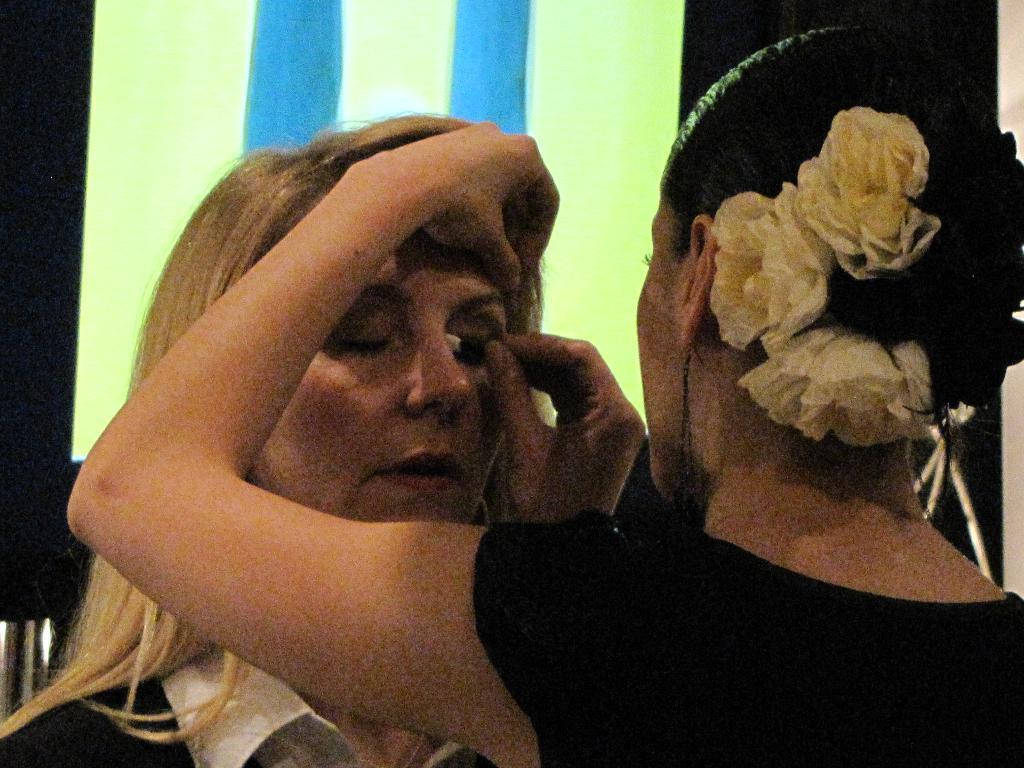What is happening in the image? In the image, there is a lady applying eye shadow to another lady. What can be seen in the background of the image? There is a board in the background of the image. What type of bird is sitting on the lady's shoulder in the image? There is no bird present in the image; it only shows a lady applying eye shadow to another lady with a board in the background. 